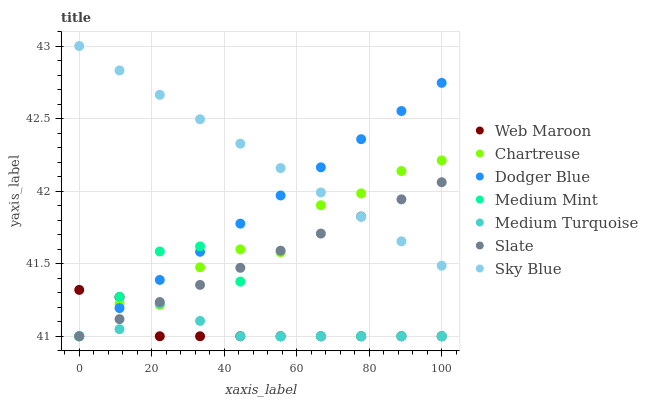Does Medium Turquoise have the minimum area under the curve?
Answer yes or no. Yes. Does Sky Blue have the maximum area under the curve?
Answer yes or no. Yes. Does Slate have the minimum area under the curve?
Answer yes or no. No. Does Slate have the maximum area under the curve?
Answer yes or no. No. Is Slate the smoothest?
Answer yes or no. Yes. Is Chartreuse the roughest?
Answer yes or no. Yes. Is Web Maroon the smoothest?
Answer yes or no. No. Is Web Maroon the roughest?
Answer yes or no. No. Does Medium Mint have the lowest value?
Answer yes or no. Yes. Does Sky Blue have the lowest value?
Answer yes or no. No. Does Sky Blue have the highest value?
Answer yes or no. Yes. Does Slate have the highest value?
Answer yes or no. No. Is Web Maroon less than Sky Blue?
Answer yes or no. Yes. Is Sky Blue greater than Web Maroon?
Answer yes or no. Yes. Does Dodger Blue intersect Sky Blue?
Answer yes or no. Yes. Is Dodger Blue less than Sky Blue?
Answer yes or no. No. Is Dodger Blue greater than Sky Blue?
Answer yes or no. No. Does Web Maroon intersect Sky Blue?
Answer yes or no. No. 